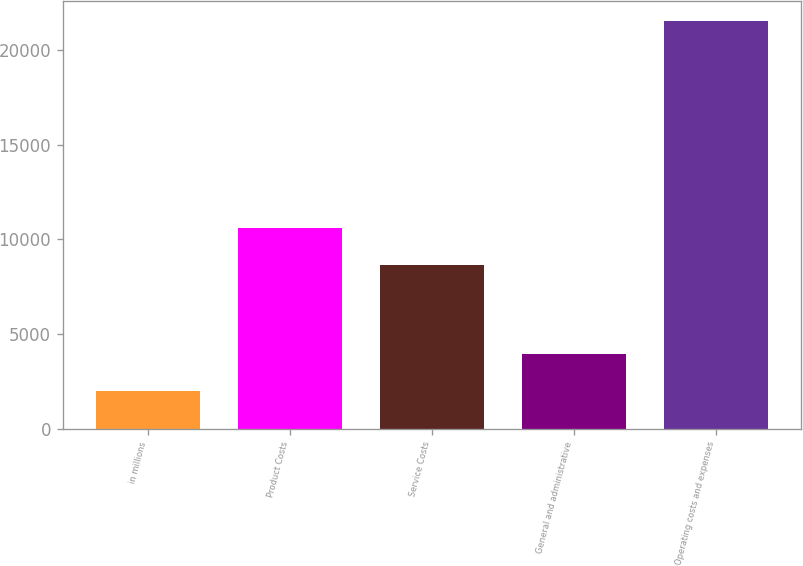Convert chart to OTSL. <chart><loc_0><loc_0><loc_500><loc_500><bar_chart><fcel>in millions<fcel>Product Costs<fcel>Service Costs<fcel>General and administrative<fcel>Operating costs and expenses<nl><fcel>2013<fcel>10623<fcel>8659<fcel>3965.5<fcel>21538<nl></chart> 